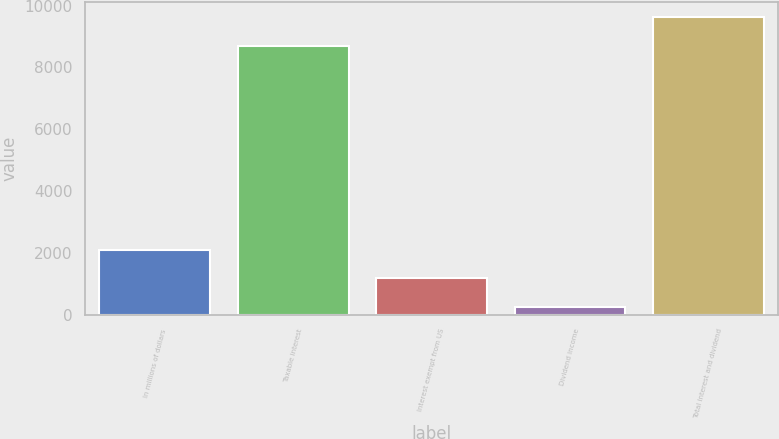<chart> <loc_0><loc_0><loc_500><loc_500><bar_chart><fcel>In millions of dollars<fcel>Taxable interest<fcel>Interest exempt from US<fcel>Dividend income<fcel>Total interest and dividend<nl><fcel>2114<fcel>8704<fcel>1191.5<fcel>269<fcel>9626.5<nl></chart> 